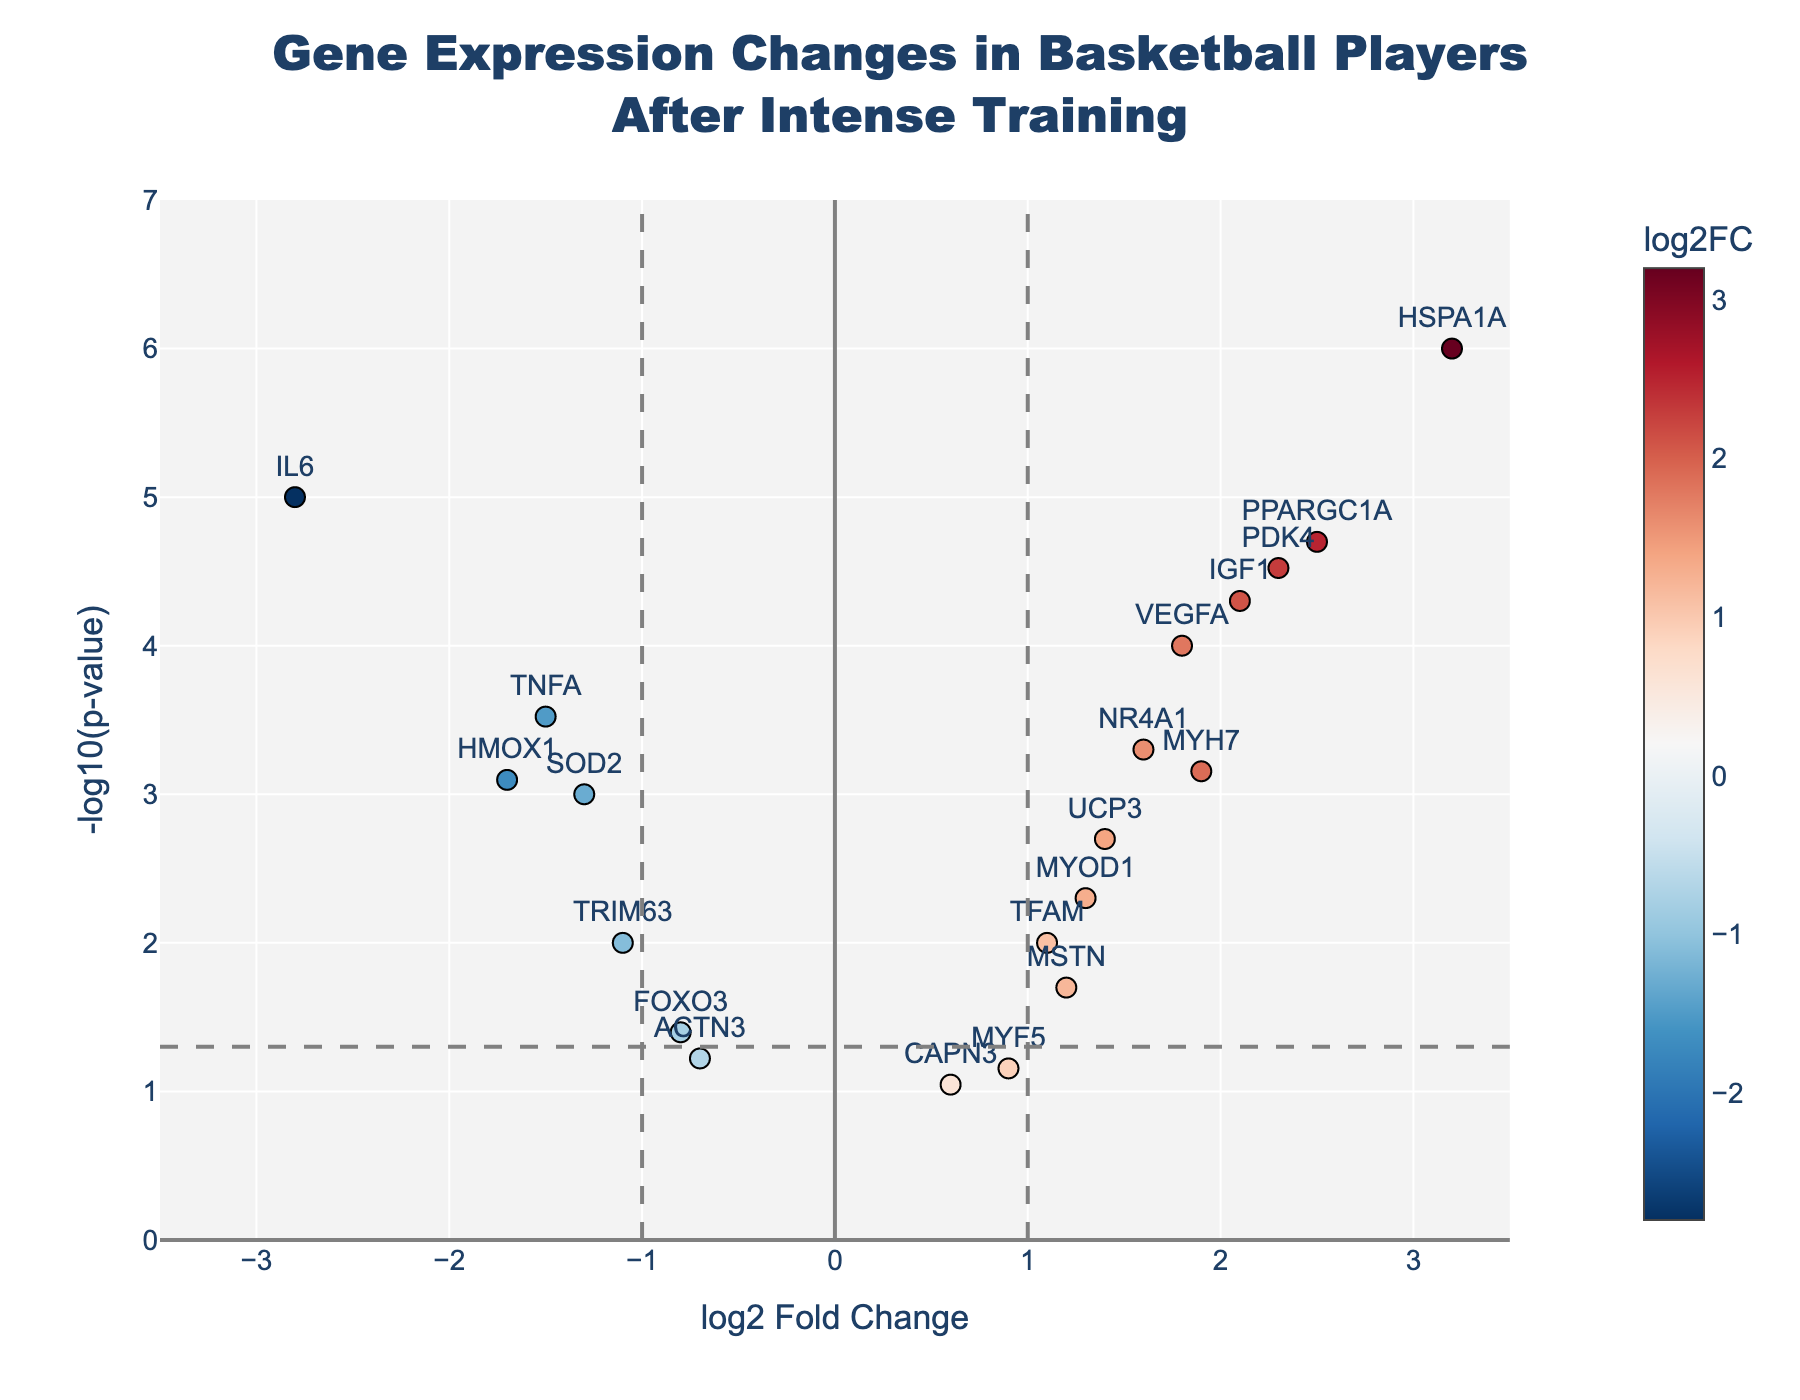What is the title of the figure? The title of the figure is prominently displayed at the top and provides an overview of what the figure is about. It reads "Gene Expression Changes in Basketball Players After Intense Training".
Answer: Gene Expression Changes in Basketball Players After Intense Training How many genes have a log2 fold change greater than 1? Looking at the x-axis (log2 Fold Change), we identify the points to the right of the vertical line at x=1. Counting these points, we find that there are 7 such genes.
Answer: 7 Which gene has the highest -log10(p-value)? The -log10(p-value) can be determined by the y-axis. The data point at the topmost position is HSPA1A, indicating it has the highest -log10(p-value).
Answer: HSPA1A Are there any genes with a log2 fold change less than -1 and a p-value less than 0.05? If so, name them. Genes with a log2 fold change less than -1 are to the left of the vertical dashed line at x=-1, and those with p-value less than 0.05 are above the horizontal dashed line. IL6 and HMOX1 meet both criteria.
Answer: IL6, HMOX1 Which gene has the highest log2 fold change? The point farthest to the right on the x-axis represents the highest log2 fold change. This gene is HSPA1A.
Answer: HSPA1A How many genes have a p-value less than 0.05? Genes with a p-value less than 0.05 are those above the horizontal dashed line. Counting these, there are 12 genes.
Answer: 12 Which genes show downregulation after intense training (log2 fold change<0)? Downregulated genes are positioned to the left of the zero line on the x-axis. These genes are IL6, TNFA, HMOX1, SOD2, FOXO3, ACTN3, and TRIM63.
Answer: IL6, TNFA, HMOX1, SOD2, FOXO3, ACTN3, TRIM63 Compare the expression changes of IL6 and IGF1. Which one is more significantly regulated and in which direction? IL6 has a log2 fold change of -2.8 and a -log10(p-value) around 5, indicating downregulation. IGF1 has a log2 fold change of 2.1 and a -log10(p-value) around 4.5, indicating upregulation. IL6 is more significantly regulated due to a higher -log10(p-value) and greater log2 fold change (absolute value).
Answer: IL6, downregulated What is the log2 fold change and p-value of PPARGC1A? Hovering over the PPARGC1A point, it shows a log2 fold change of 2.5 and a p-value of 0.00002.
Answer: log2 fold change: 2.5, p-value: 0.00002 Which genes have a log2 fold change between 1 and 2 and are statistically significant (p-value < 0.05)? Observing the points within the range of 1 < log2 fold change < 2 and above the significance threshold line, we identify MYH7, NR4A1, TFAM, and UCP3.
Answer: MYH7, NR4A1, TFAM, UCP3 